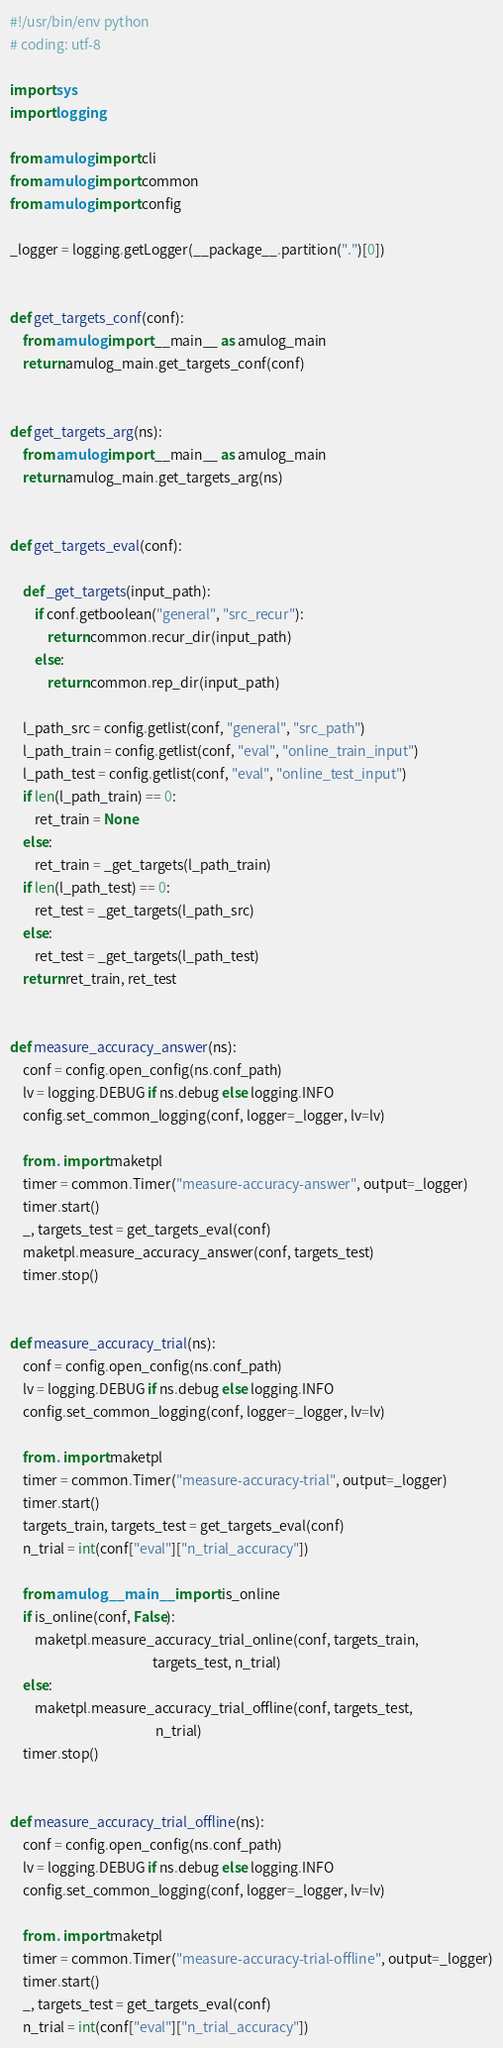<code> <loc_0><loc_0><loc_500><loc_500><_Python_>#!/usr/bin/env python
# coding: utf-8

import sys
import logging

from amulog import cli
from amulog import common
from amulog import config

_logger = logging.getLogger(__package__.partition(".")[0])


def get_targets_conf(conf):
    from amulog import __main__ as amulog_main
    return amulog_main.get_targets_conf(conf)


def get_targets_arg(ns):
    from amulog import __main__ as amulog_main
    return amulog_main.get_targets_arg(ns)


def get_targets_eval(conf):

    def _get_targets(input_path):
        if conf.getboolean("general", "src_recur"):
            return common.recur_dir(input_path)
        else:
            return common.rep_dir(input_path)

    l_path_src = config.getlist(conf, "general", "src_path")
    l_path_train = config.getlist(conf, "eval", "online_train_input")
    l_path_test = config.getlist(conf, "eval", "online_test_input")
    if len(l_path_train) == 0:
        ret_train = None
    else:
        ret_train = _get_targets(l_path_train)
    if len(l_path_test) == 0:
        ret_test = _get_targets(l_path_src)
    else:
        ret_test = _get_targets(l_path_test)
    return ret_train, ret_test


def measure_accuracy_answer(ns):
    conf = config.open_config(ns.conf_path)
    lv = logging.DEBUG if ns.debug else logging.INFO
    config.set_common_logging(conf, logger=_logger, lv=lv)

    from . import maketpl
    timer = common.Timer("measure-accuracy-answer", output=_logger)
    timer.start()
    _, targets_test = get_targets_eval(conf)
    maketpl.measure_accuracy_answer(conf, targets_test)
    timer.stop()


def measure_accuracy_trial(ns):
    conf = config.open_config(ns.conf_path)
    lv = logging.DEBUG if ns.debug else logging.INFO
    config.set_common_logging(conf, logger=_logger, lv=lv)

    from . import maketpl
    timer = common.Timer("measure-accuracy-trial", output=_logger)
    timer.start()
    targets_train, targets_test = get_targets_eval(conf)
    n_trial = int(conf["eval"]["n_trial_accuracy"])

    from amulog.__main__ import is_online
    if is_online(conf, False):
        maketpl.measure_accuracy_trial_online(conf, targets_train,
                                              targets_test, n_trial)
    else:
        maketpl.measure_accuracy_trial_offline(conf, targets_test,
                                               n_trial)
    timer.stop()


def measure_accuracy_trial_offline(ns):
    conf = config.open_config(ns.conf_path)
    lv = logging.DEBUG if ns.debug else logging.INFO
    config.set_common_logging(conf, logger=_logger, lv=lv)

    from . import maketpl
    timer = common.Timer("measure-accuracy-trial-offline", output=_logger)
    timer.start()
    _, targets_test = get_targets_eval(conf)
    n_trial = int(conf["eval"]["n_trial_accuracy"])</code> 